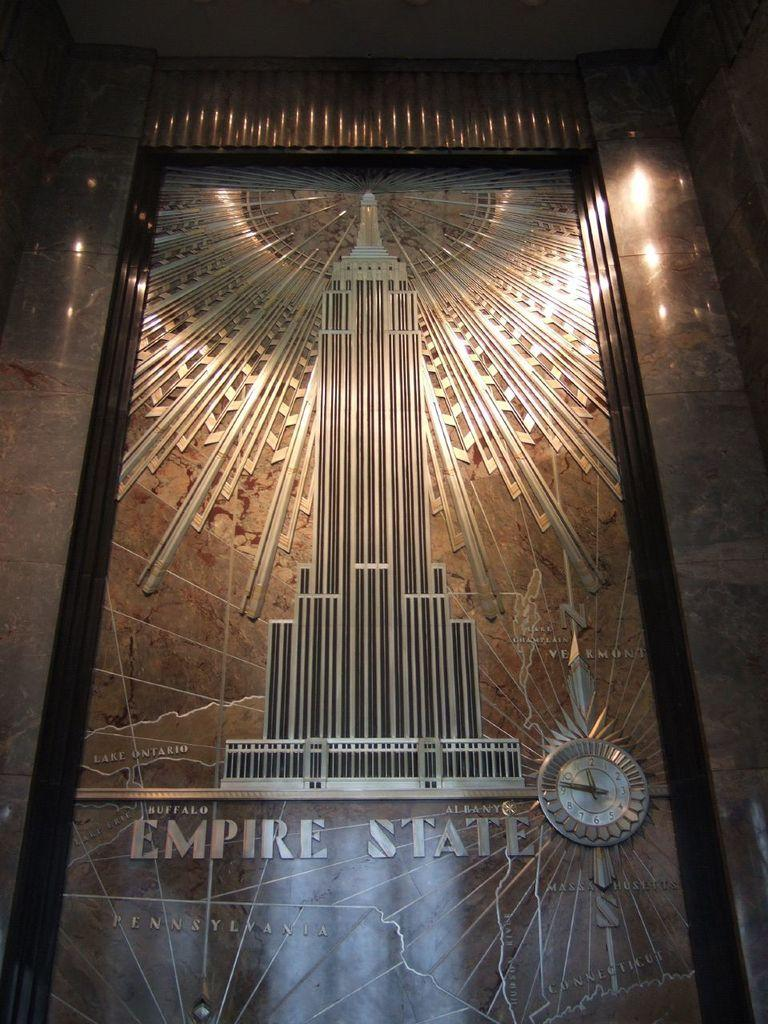<image>
Relay a brief, clear account of the picture shown. A picture of the Empire State Building is engraved into a marble wall 